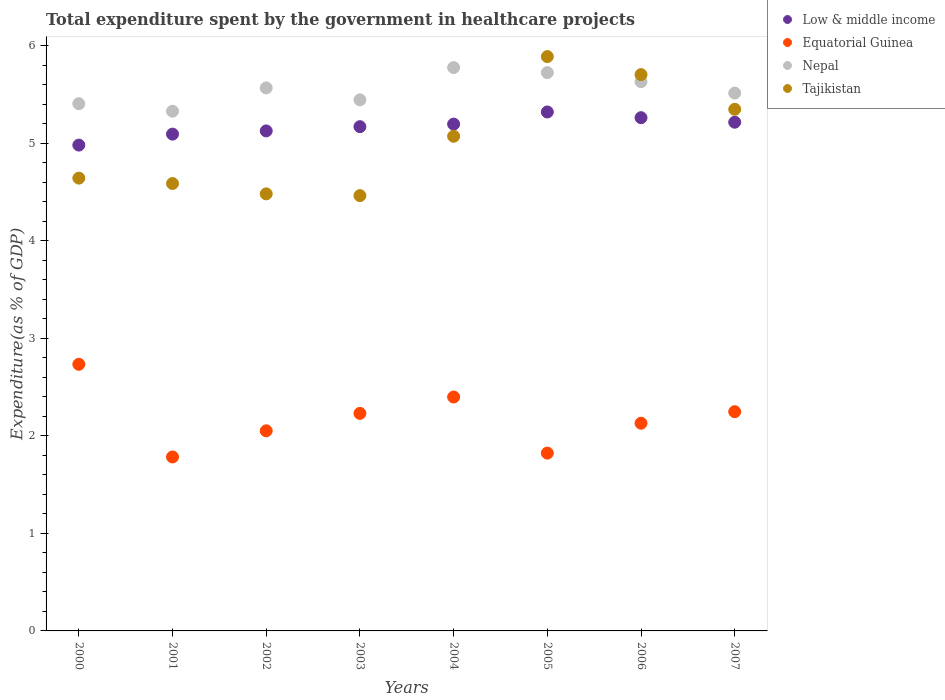What is the total expenditure spent by the government in healthcare projects in Tajikistan in 2004?
Your response must be concise. 5.07. Across all years, what is the maximum total expenditure spent by the government in healthcare projects in Equatorial Guinea?
Offer a very short reply. 2.73. Across all years, what is the minimum total expenditure spent by the government in healthcare projects in Low & middle income?
Provide a short and direct response. 4.98. What is the total total expenditure spent by the government in healthcare projects in Tajikistan in the graph?
Provide a succinct answer. 40.17. What is the difference between the total expenditure spent by the government in healthcare projects in Low & middle income in 2000 and that in 2006?
Keep it short and to the point. -0.28. What is the difference between the total expenditure spent by the government in healthcare projects in Equatorial Guinea in 2006 and the total expenditure spent by the government in healthcare projects in Low & middle income in 2001?
Make the answer very short. -2.96. What is the average total expenditure spent by the government in healthcare projects in Low & middle income per year?
Ensure brevity in your answer.  5.17. In the year 2006, what is the difference between the total expenditure spent by the government in healthcare projects in Tajikistan and total expenditure spent by the government in healthcare projects in Equatorial Guinea?
Ensure brevity in your answer.  3.57. In how many years, is the total expenditure spent by the government in healthcare projects in Equatorial Guinea greater than 5.4 %?
Keep it short and to the point. 0. What is the ratio of the total expenditure spent by the government in healthcare projects in Low & middle income in 2000 to that in 2002?
Your answer should be compact. 0.97. Is the total expenditure spent by the government in healthcare projects in Equatorial Guinea in 2003 less than that in 2004?
Provide a short and direct response. Yes. What is the difference between the highest and the second highest total expenditure spent by the government in healthcare projects in Tajikistan?
Provide a succinct answer. 0.18. What is the difference between the highest and the lowest total expenditure spent by the government in healthcare projects in Nepal?
Offer a very short reply. 0.45. Is the sum of the total expenditure spent by the government in healthcare projects in Equatorial Guinea in 2000 and 2004 greater than the maximum total expenditure spent by the government in healthcare projects in Tajikistan across all years?
Make the answer very short. No. Is it the case that in every year, the sum of the total expenditure spent by the government in healthcare projects in Tajikistan and total expenditure spent by the government in healthcare projects in Nepal  is greater than the total expenditure spent by the government in healthcare projects in Equatorial Guinea?
Your answer should be compact. Yes. Is the total expenditure spent by the government in healthcare projects in Equatorial Guinea strictly less than the total expenditure spent by the government in healthcare projects in Tajikistan over the years?
Make the answer very short. Yes. How many dotlines are there?
Your answer should be compact. 4. How many years are there in the graph?
Your response must be concise. 8. What is the difference between two consecutive major ticks on the Y-axis?
Provide a short and direct response. 1. Does the graph contain grids?
Provide a short and direct response. No. How are the legend labels stacked?
Your answer should be very brief. Vertical. What is the title of the graph?
Your answer should be very brief. Total expenditure spent by the government in healthcare projects. Does "Cuba" appear as one of the legend labels in the graph?
Offer a very short reply. No. What is the label or title of the X-axis?
Provide a short and direct response. Years. What is the label or title of the Y-axis?
Make the answer very short. Expenditure(as % of GDP). What is the Expenditure(as % of GDP) of Low & middle income in 2000?
Your answer should be very brief. 4.98. What is the Expenditure(as % of GDP) in Equatorial Guinea in 2000?
Give a very brief answer. 2.73. What is the Expenditure(as % of GDP) in Nepal in 2000?
Provide a short and direct response. 5.4. What is the Expenditure(as % of GDP) in Tajikistan in 2000?
Offer a terse response. 4.64. What is the Expenditure(as % of GDP) of Low & middle income in 2001?
Offer a very short reply. 5.09. What is the Expenditure(as % of GDP) in Equatorial Guinea in 2001?
Offer a terse response. 1.78. What is the Expenditure(as % of GDP) in Nepal in 2001?
Your response must be concise. 5.33. What is the Expenditure(as % of GDP) of Tajikistan in 2001?
Your answer should be very brief. 4.59. What is the Expenditure(as % of GDP) of Low & middle income in 2002?
Provide a short and direct response. 5.13. What is the Expenditure(as % of GDP) in Equatorial Guinea in 2002?
Your answer should be compact. 2.05. What is the Expenditure(as % of GDP) of Nepal in 2002?
Your response must be concise. 5.57. What is the Expenditure(as % of GDP) in Tajikistan in 2002?
Ensure brevity in your answer.  4.48. What is the Expenditure(as % of GDP) in Low & middle income in 2003?
Offer a very short reply. 5.17. What is the Expenditure(as % of GDP) in Equatorial Guinea in 2003?
Your response must be concise. 2.23. What is the Expenditure(as % of GDP) of Nepal in 2003?
Your answer should be very brief. 5.44. What is the Expenditure(as % of GDP) in Tajikistan in 2003?
Ensure brevity in your answer.  4.46. What is the Expenditure(as % of GDP) in Low & middle income in 2004?
Your answer should be very brief. 5.19. What is the Expenditure(as % of GDP) in Equatorial Guinea in 2004?
Your answer should be very brief. 2.4. What is the Expenditure(as % of GDP) of Nepal in 2004?
Keep it short and to the point. 5.77. What is the Expenditure(as % of GDP) of Tajikistan in 2004?
Ensure brevity in your answer.  5.07. What is the Expenditure(as % of GDP) of Low & middle income in 2005?
Your answer should be compact. 5.32. What is the Expenditure(as % of GDP) of Equatorial Guinea in 2005?
Provide a short and direct response. 1.82. What is the Expenditure(as % of GDP) of Nepal in 2005?
Keep it short and to the point. 5.72. What is the Expenditure(as % of GDP) in Tajikistan in 2005?
Make the answer very short. 5.89. What is the Expenditure(as % of GDP) in Low & middle income in 2006?
Make the answer very short. 5.26. What is the Expenditure(as % of GDP) in Equatorial Guinea in 2006?
Offer a very short reply. 2.13. What is the Expenditure(as % of GDP) in Nepal in 2006?
Make the answer very short. 5.63. What is the Expenditure(as % of GDP) of Tajikistan in 2006?
Offer a very short reply. 5.7. What is the Expenditure(as % of GDP) of Low & middle income in 2007?
Keep it short and to the point. 5.21. What is the Expenditure(as % of GDP) of Equatorial Guinea in 2007?
Keep it short and to the point. 2.25. What is the Expenditure(as % of GDP) of Nepal in 2007?
Give a very brief answer. 5.51. What is the Expenditure(as % of GDP) in Tajikistan in 2007?
Give a very brief answer. 5.35. Across all years, what is the maximum Expenditure(as % of GDP) of Low & middle income?
Make the answer very short. 5.32. Across all years, what is the maximum Expenditure(as % of GDP) of Equatorial Guinea?
Make the answer very short. 2.73. Across all years, what is the maximum Expenditure(as % of GDP) in Nepal?
Keep it short and to the point. 5.77. Across all years, what is the maximum Expenditure(as % of GDP) in Tajikistan?
Provide a succinct answer. 5.89. Across all years, what is the minimum Expenditure(as % of GDP) of Low & middle income?
Provide a short and direct response. 4.98. Across all years, what is the minimum Expenditure(as % of GDP) in Equatorial Guinea?
Offer a very short reply. 1.78. Across all years, what is the minimum Expenditure(as % of GDP) of Nepal?
Ensure brevity in your answer.  5.33. Across all years, what is the minimum Expenditure(as % of GDP) in Tajikistan?
Offer a very short reply. 4.46. What is the total Expenditure(as % of GDP) in Low & middle income in the graph?
Make the answer very short. 41.35. What is the total Expenditure(as % of GDP) in Equatorial Guinea in the graph?
Ensure brevity in your answer.  17.39. What is the total Expenditure(as % of GDP) in Nepal in the graph?
Keep it short and to the point. 44.38. What is the total Expenditure(as % of GDP) in Tajikistan in the graph?
Provide a succinct answer. 40.17. What is the difference between the Expenditure(as % of GDP) in Low & middle income in 2000 and that in 2001?
Offer a very short reply. -0.11. What is the difference between the Expenditure(as % of GDP) of Equatorial Guinea in 2000 and that in 2001?
Your response must be concise. 0.95. What is the difference between the Expenditure(as % of GDP) in Nepal in 2000 and that in 2001?
Provide a succinct answer. 0.08. What is the difference between the Expenditure(as % of GDP) in Tajikistan in 2000 and that in 2001?
Your answer should be compact. 0.06. What is the difference between the Expenditure(as % of GDP) in Low & middle income in 2000 and that in 2002?
Give a very brief answer. -0.15. What is the difference between the Expenditure(as % of GDP) of Equatorial Guinea in 2000 and that in 2002?
Give a very brief answer. 0.68. What is the difference between the Expenditure(as % of GDP) of Nepal in 2000 and that in 2002?
Offer a very short reply. -0.16. What is the difference between the Expenditure(as % of GDP) in Tajikistan in 2000 and that in 2002?
Give a very brief answer. 0.16. What is the difference between the Expenditure(as % of GDP) in Low & middle income in 2000 and that in 2003?
Your response must be concise. -0.19. What is the difference between the Expenditure(as % of GDP) of Equatorial Guinea in 2000 and that in 2003?
Offer a terse response. 0.5. What is the difference between the Expenditure(as % of GDP) of Nepal in 2000 and that in 2003?
Offer a very short reply. -0.04. What is the difference between the Expenditure(as % of GDP) in Tajikistan in 2000 and that in 2003?
Offer a very short reply. 0.18. What is the difference between the Expenditure(as % of GDP) of Low & middle income in 2000 and that in 2004?
Keep it short and to the point. -0.21. What is the difference between the Expenditure(as % of GDP) in Equatorial Guinea in 2000 and that in 2004?
Provide a succinct answer. 0.34. What is the difference between the Expenditure(as % of GDP) of Nepal in 2000 and that in 2004?
Offer a very short reply. -0.37. What is the difference between the Expenditure(as % of GDP) in Tajikistan in 2000 and that in 2004?
Keep it short and to the point. -0.43. What is the difference between the Expenditure(as % of GDP) of Low & middle income in 2000 and that in 2005?
Provide a short and direct response. -0.34. What is the difference between the Expenditure(as % of GDP) in Equatorial Guinea in 2000 and that in 2005?
Keep it short and to the point. 0.91. What is the difference between the Expenditure(as % of GDP) of Nepal in 2000 and that in 2005?
Provide a succinct answer. -0.32. What is the difference between the Expenditure(as % of GDP) of Tajikistan in 2000 and that in 2005?
Provide a succinct answer. -1.25. What is the difference between the Expenditure(as % of GDP) in Low & middle income in 2000 and that in 2006?
Offer a terse response. -0.28. What is the difference between the Expenditure(as % of GDP) in Equatorial Guinea in 2000 and that in 2006?
Give a very brief answer. 0.6. What is the difference between the Expenditure(as % of GDP) of Nepal in 2000 and that in 2006?
Keep it short and to the point. -0.23. What is the difference between the Expenditure(as % of GDP) of Tajikistan in 2000 and that in 2006?
Make the answer very short. -1.06. What is the difference between the Expenditure(as % of GDP) in Low & middle income in 2000 and that in 2007?
Give a very brief answer. -0.23. What is the difference between the Expenditure(as % of GDP) of Equatorial Guinea in 2000 and that in 2007?
Provide a short and direct response. 0.49. What is the difference between the Expenditure(as % of GDP) of Nepal in 2000 and that in 2007?
Your response must be concise. -0.11. What is the difference between the Expenditure(as % of GDP) of Tajikistan in 2000 and that in 2007?
Give a very brief answer. -0.71. What is the difference between the Expenditure(as % of GDP) of Low & middle income in 2001 and that in 2002?
Offer a terse response. -0.03. What is the difference between the Expenditure(as % of GDP) of Equatorial Guinea in 2001 and that in 2002?
Your answer should be compact. -0.27. What is the difference between the Expenditure(as % of GDP) of Nepal in 2001 and that in 2002?
Give a very brief answer. -0.24. What is the difference between the Expenditure(as % of GDP) of Tajikistan in 2001 and that in 2002?
Keep it short and to the point. 0.11. What is the difference between the Expenditure(as % of GDP) of Low & middle income in 2001 and that in 2003?
Your answer should be compact. -0.08. What is the difference between the Expenditure(as % of GDP) in Equatorial Guinea in 2001 and that in 2003?
Ensure brevity in your answer.  -0.45. What is the difference between the Expenditure(as % of GDP) in Nepal in 2001 and that in 2003?
Your response must be concise. -0.12. What is the difference between the Expenditure(as % of GDP) in Tajikistan in 2001 and that in 2003?
Offer a terse response. 0.12. What is the difference between the Expenditure(as % of GDP) of Low & middle income in 2001 and that in 2004?
Your response must be concise. -0.1. What is the difference between the Expenditure(as % of GDP) in Equatorial Guinea in 2001 and that in 2004?
Your answer should be compact. -0.61. What is the difference between the Expenditure(as % of GDP) of Nepal in 2001 and that in 2004?
Your response must be concise. -0.45. What is the difference between the Expenditure(as % of GDP) in Tajikistan in 2001 and that in 2004?
Provide a short and direct response. -0.48. What is the difference between the Expenditure(as % of GDP) in Low & middle income in 2001 and that in 2005?
Keep it short and to the point. -0.23. What is the difference between the Expenditure(as % of GDP) in Equatorial Guinea in 2001 and that in 2005?
Provide a short and direct response. -0.04. What is the difference between the Expenditure(as % of GDP) of Nepal in 2001 and that in 2005?
Give a very brief answer. -0.4. What is the difference between the Expenditure(as % of GDP) in Tajikistan in 2001 and that in 2005?
Give a very brief answer. -1.3. What is the difference between the Expenditure(as % of GDP) of Low & middle income in 2001 and that in 2006?
Ensure brevity in your answer.  -0.17. What is the difference between the Expenditure(as % of GDP) of Equatorial Guinea in 2001 and that in 2006?
Ensure brevity in your answer.  -0.35. What is the difference between the Expenditure(as % of GDP) of Nepal in 2001 and that in 2006?
Your response must be concise. -0.3. What is the difference between the Expenditure(as % of GDP) of Tajikistan in 2001 and that in 2006?
Your response must be concise. -1.12. What is the difference between the Expenditure(as % of GDP) in Low & middle income in 2001 and that in 2007?
Make the answer very short. -0.12. What is the difference between the Expenditure(as % of GDP) of Equatorial Guinea in 2001 and that in 2007?
Provide a succinct answer. -0.46. What is the difference between the Expenditure(as % of GDP) in Nepal in 2001 and that in 2007?
Your answer should be compact. -0.19. What is the difference between the Expenditure(as % of GDP) in Tajikistan in 2001 and that in 2007?
Give a very brief answer. -0.76. What is the difference between the Expenditure(as % of GDP) in Low & middle income in 2002 and that in 2003?
Offer a terse response. -0.04. What is the difference between the Expenditure(as % of GDP) in Equatorial Guinea in 2002 and that in 2003?
Your answer should be compact. -0.18. What is the difference between the Expenditure(as % of GDP) in Nepal in 2002 and that in 2003?
Keep it short and to the point. 0.12. What is the difference between the Expenditure(as % of GDP) of Tajikistan in 2002 and that in 2003?
Your answer should be compact. 0.02. What is the difference between the Expenditure(as % of GDP) of Low & middle income in 2002 and that in 2004?
Keep it short and to the point. -0.07. What is the difference between the Expenditure(as % of GDP) of Equatorial Guinea in 2002 and that in 2004?
Offer a terse response. -0.35. What is the difference between the Expenditure(as % of GDP) in Nepal in 2002 and that in 2004?
Your answer should be compact. -0.21. What is the difference between the Expenditure(as % of GDP) of Tajikistan in 2002 and that in 2004?
Provide a short and direct response. -0.59. What is the difference between the Expenditure(as % of GDP) in Low & middle income in 2002 and that in 2005?
Make the answer very short. -0.19. What is the difference between the Expenditure(as % of GDP) of Equatorial Guinea in 2002 and that in 2005?
Your answer should be very brief. 0.23. What is the difference between the Expenditure(as % of GDP) of Nepal in 2002 and that in 2005?
Your answer should be very brief. -0.16. What is the difference between the Expenditure(as % of GDP) in Tajikistan in 2002 and that in 2005?
Ensure brevity in your answer.  -1.41. What is the difference between the Expenditure(as % of GDP) of Low & middle income in 2002 and that in 2006?
Your answer should be compact. -0.14. What is the difference between the Expenditure(as % of GDP) in Equatorial Guinea in 2002 and that in 2006?
Provide a succinct answer. -0.08. What is the difference between the Expenditure(as % of GDP) in Nepal in 2002 and that in 2006?
Your answer should be compact. -0.06. What is the difference between the Expenditure(as % of GDP) of Tajikistan in 2002 and that in 2006?
Make the answer very short. -1.22. What is the difference between the Expenditure(as % of GDP) of Low & middle income in 2002 and that in 2007?
Provide a succinct answer. -0.09. What is the difference between the Expenditure(as % of GDP) of Equatorial Guinea in 2002 and that in 2007?
Your answer should be very brief. -0.2. What is the difference between the Expenditure(as % of GDP) of Nepal in 2002 and that in 2007?
Offer a very short reply. 0.05. What is the difference between the Expenditure(as % of GDP) in Tajikistan in 2002 and that in 2007?
Your answer should be compact. -0.87. What is the difference between the Expenditure(as % of GDP) in Low & middle income in 2003 and that in 2004?
Your answer should be very brief. -0.03. What is the difference between the Expenditure(as % of GDP) in Equatorial Guinea in 2003 and that in 2004?
Ensure brevity in your answer.  -0.17. What is the difference between the Expenditure(as % of GDP) in Nepal in 2003 and that in 2004?
Make the answer very short. -0.33. What is the difference between the Expenditure(as % of GDP) of Tajikistan in 2003 and that in 2004?
Provide a succinct answer. -0.61. What is the difference between the Expenditure(as % of GDP) in Low & middle income in 2003 and that in 2005?
Your response must be concise. -0.15. What is the difference between the Expenditure(as % of GDP) of Equatorial Guinea in 2003 and that in 2005?
Your answer should be compact. 0.41. What is the difference between the Expenditure(as % of GDP) in Nepal in 2003 and that in 2005?
Your answer should be compact. -0.28. What is the difference between the Expenditure(as % of GDP) in Tajikistan in 2003 and that in 2005?
Offer a very short reply. -1.43. What is the difference between the Expenditure(as % of GDP) in Low & middle income in 2003 and that in 2006?
Your answer should be compact. -0.09. What is the difference between the Expenditure(as % of GDP) of Equatorial Guinea in 2003 and that in 2006?
Provide a short and direct response. 0.1. What is the difference between the Expenditure(as % of GDP) in Nepal in 2003 and that in 2006?
Make the answer very short. -0.19. What is the difference between the Expenditure(as % of GDP) in Tajikistan in 2003 and that in 2006?
Provide a short and direct response. -1.24. What is the difference between the Expenditure(as % of GDP) in Low & middle income in 2003 and that in 2007?
Your response must be concise. -0.05. What is the difference between the Expenditure(as % of GDP) of Equatorial Guinea in 2003 and that in 2007?
Provide a short and direct response. -0.02. What is the difference between the Expenditure(as % of GDP) in Nepal in 2003 and that in 2007?
Provide a succinct answer. -0.07. What is the difference between the Expenditure(as % of GDP) in Tajikistan in 2003 and that in 2007?
Ensure brevity in your answer.  -0.88. What is the difference between the Expenditure(as % of GDP) of Low & middle income in 2004 and that in 2005?
Ensure brevity in your answer.  -0.12. What is the difference between the Expenditure(as % of GDP) of Equatorial Guinea in 2004 and that in 2005?
Your answer should be compact. 0.57. What is the difference between the Expenditure(as % of GDP) in Nepal in 2004 and that in 2005?
Your answer should be compact. 0.05. What is the difference between the Expenditure(as % of GDP) of Tajikistan in 2004 and that in 2005?
Offer a terse response. -0.82. What is the difference between the Expenditure(as % of GDP) of Low & middle income in 2004 and that in 2006?
Give a very brief answer. -0.07. What is the difference between the Expenditure(as % of GDP) in Equatorial Guinea in 2004 and that in 2006?
Your answer should be very brief. 0.27. What is the difference between the Expenditure(as % of GDP) of Nepal in 2004 and that in 2006?
Ensure brevity in your answer.  0.14. What is the difference between the Expenditure(as % of GDP) of Tajikistan in 2004 and that in 2006?
Provide a succinct answer. -0.63. What is the difference between the Expenditure(as % of GDP) of Low & middle income in 2004 and that in 2007?
Offer a terse response. -0.02. What is the difference between the Expenditure(as % of GDP) in Equatorial Guinea in 2004 and that in 2007?
Keep it short and to the point. 0.15. What is the difference between the Expenditure(as % of GDP) of Nepal in 2004 and that in 2007?
Offer a terse response. 0.26. What is the difference between the Expenditure(as % of GDP) in Tajikistan in 2004 and that in 2007?
Your response must be concise. -0.28. What is the difference between the Expenditure(as % of GDP) in Low & middle income in 2005 and that in 2006?
Ensure brevity in your answer.  0.06. What is the difference between the Expenditure(as % of GDP) in Equatorial Guinea in 2005 and that in 2006?
Your answer should be very brief. -0.31. What is the difference between the Expenditure(as % of GDP) in Nepal in 2005 and that in 2006?
Give a very brief answer. 0.09. What is the difference between the Expenditure(as % of GDP) in Tajikistan in 2005 and that in 2006?
Give a very brief answer. 0.18. What is the difference between the Expenditure(as % of GDP) of Low & middle income in 2005 and that in 2007?
Offer a terse response. 0.1. What is the difference between the Expenditure(as % of GDP) in Equatorial Guinea in 2005 and that in 2007?
Your response must be concise. -0.42. What is the difference between the Expenditure(as % of GDP) of Nepal in 2005 and that in 2007?
Offer a very short reply. 0.21. What is the difference between the Expenditure(as % of GDP) in Tajikistan in 2005 and that in 2007?
Make the answer very short. 0.54. What is the difference between the Expenditure(as % of GDP) in Low & middle income in 2006 and that in 2007?
Provide a short and direct response. 0.05. What is the difference between the Expenditure(as % of GDP) in Equatorial Guinea in 2006 and that in 2007?
Offer a terse response. -0.12. What is the difference between the Expenditure(as % of GDP) of Nepal in 2006 and that in 2007?
Make the answer very short. 0.12. What is the difference between the Expenditure(as % of GDP) of Tajikistan in 2006 and that in 2007?
Keep it short and to the point. 0.36. What is the difference between the Expenditure(as % of GDP) of Low & middle income in 2000 and the Expenditure(as % of GDP) of Equatorial Guinea in 2001?
Your answer should be compact. 3.2. What is the difference between the Expenditure(as % of GDP) of Low & middle income in 2000 and the Expenditure(as % of GDP) of Nepal in 2001?
Provide a short and direct response. -0.35. What is the difference between the Expenditure(as % of GDP) in Low & middle income in 2000 and the Expenditure(as % of GDP) in Tajikistan in 2001?
Make the answer very short. 0.39. What is the difference between the Expenditure(as % of GDP) in Equatorial Guinea in 2000 and the Expenditure(as % of GDP) in Nepal in 2001?
Make the answer very short. -2.59. What is the difference between the Expenditure(as % of GDP) in Equatorial Guinea in 2000 and the Expenditure(as % of GDP) in Tajikistan in 2001?
Make the answer very short. -1.85. What is the difference between the Expenditure(as % of GDP) of Nepal in 2000 and the Expenditure(as % of GDP) of Tajikistan in 2001?
Make the answer very short. 0.82. What is the difference between the Expenditure(as % of GDP) in Low & middle income in 2000 and the Expenditure(as % of GDP) in Equatorial Guinea in 2002?
Keep it short and to the point. 2.93. What is the difference between the Expenditure(as % of GDP) of Low & middle income in 2000 and the Expenditure(as % of GDP) of Nepal in 2002?
Make the answer very short. -0.59. What is the difference between the Expenditure(as % of GDP) of Low & middle income in 2000 and the Expenditure(as % of GDP) of Tajikistan in 2002?
Provide a short and direct response. 0.5. What is the difference between the Expenditure(as % of GDP) of Equatorial Guinea in 2000 and the Expenditure(as % of GDP) of Nepal in 2002?
Give a very brief answer. -2.83. What is the difference between the Expenditure(as % of GDP) in Equatorial Guinea in 2000 and the Expenditure(as % of GDP) in Tajikistan in 2002?
Your response must be concise. -1.75. What is the difference between the Expenditure(as % of GDP) in Nepal in 2000 and the Expenditure(as % of GDP) in Tajikistan in 2002?
Ensure brevity in your answer.  0.92. What is the difference between the Expenditure(as % of GDP) of Low & middle income in 2000 and the Expenditure(as % of GDP) of Equatorial Guinea in 2003?
Offer a terse response. 2.75. What is the difference between the Expenditure(as % of GDP) of Low & middle income in 2000 and the Expenditure(as % of GDP) of Nepal in 2003?
Offer a terse response. -0.46. What is the difference between the Expenditure(as % of GDP) in Low & middle income in 2000 and the Expenditure(as % of GDP) in Tajikistan in 2003?
Offer a very short reply. 0.52. What is the difference between the Expenditure(as % of GDP) of Equatorial Guinea in 2000 and the Expenditure(as % of GDP) of Nepal in 2003?
Give a very brief answer. -2.71. What is the difference between the Expenditure(as % of GDP) in Equatorial Guinea in 2000 and the Expenditure(as % of GDP) in Tajikistan in 2003?
Offer a very short reply. -1.73. What is the difference between the Expenditure(as % of GDP) in Nepal in 2000 and the Expenditure(as % of GDP) in Tajikistan in 2003?
Provide a succinct answer. 0.94. What is the difference between the Expenditure(as % of GDP) of Low & middle income in 2000 and the Expenditure(as % of GDP) of Equatorial Guinea in 2004?
Your answer should be very brief. 2.58. What is the difference between the Expenditure(as % of GDP) in Low & middle income in 2000 and the Expenditure(as % of GDP) in Nepal in 2004?
Offer a very short reply. -0.79. What is the difference between the Expenditure(as % of GDP) of Low & middle income in 2000 and the Expenditure(as % of GDP) of Tajikistan in 2004?
Provide a short and direct response. -0.09. What is the difference between the Expenditure(as % of GDP) in Equatorial Guinea in 2000 and the Expenditure(as % of GDP) in Nepal in 2004?
Provide a short and direct response. -3.04. What is the difference between the Expenditure(as % of GDP) in Equatorial Guinea in 2000 and the Expenditure(as % of GDP) in Tajikistan in 2004?
Offer a very short reply. -2.34. What is the difference between the Expenditure(as % of GDP) of Nepal in 2000 and the Expenditure(as % of GDP) of Tajikistan in 2004?
Offer a terse response. 0.33. What is the difference between the Expenditure(as % of GDP) in Low & middle income in 2000 and the Expenditure(as % of GDP) in Equatorial Guinea in 2005?
Provide a short and direct response. 3.16. What is the difference between the Expenditure(as % of GDP) in Low & middle income in 2000 and the Expenditure(as % of GDP) in Nepal in 2005?
Your answer should be compact. -0.74. What is the difference between the Expenditure(as % of GDP) of Low & middle income in 2000 and the Expenditure(as % of GDP) of Tajikistan in 2005?
Your answer should be very brief. -0.91. What is the difference between the Expenditure(as % of GDP) of Equatorial Guinea in 2000 and the Expenditure(as % of GDP) of Nepal in 2005?
Give a very brief answer. -2.99. What is the difference between the Expenditure(as % of GDP) in Equatorial Guinea in 2000 and the Expenditure(as % of GDP) in Tajikistan in 2005?
Provide a succinct answer. -3.15. What is the difference between the Expenditure(as % of GDP) in Nepal in 2000 and the Expenditure(as % of GDP) in Tajikistan in 2005?
Your response must be concise. -0.48. What is the difference between the Expenditure(as % of GDP) in Low & middle income in 2000 and the Expenditure(as % of GDP) in Equatorial Guinea in 2006?
Your answer should be very brief. 2.85. What is the difference between the Expenditure(as % of GDP) of Low & middle income in 2000 and the Expenditure(as % of GDP) of Nepal in 2006?
Your answer should be very brief. -0.65. What is the difference between the Expenditure(as % of GDP) of Low & middle income in 2000 and the Expenditure(as % of GDP) of Tajikistan in 2006?
Your answer should be very brief. -0.72. What is the difference between the Expenditure(as % of GDP) in Equatorial Guinea in 2000 and the Expenditure(as % of GDP) in Nepal in 2006?
Offer a terse response. -2.9. What is the difference between the Expenditure(as % of GDP) in Equatorial Guinea in 2000 and the Expenditure(as % of GDP) in Tajikistan in 2006?
Offer a very short reply. -2.97. What is the difference between the Expenditure(as % of GDP) in Nepal in 2000 and the Expenditure(as % of GDP) in Tajikistan in 2006?
Your answer should be very brief. -0.3. What is the difference between the Expenditure(as % of GDP) of Low & middle income in 2000 and the Expenditure(as % of GDP) of Equatorial Guinea in 2007?
Your response must be concise. 2.73. What is the difference between the Expenditure(as % of GDP) in Low & middle income in 2000 and the Expenditure(as % of GDP) in Nepal in 2007?
Offer a very short reply. -0.53. What is the difference between the Expenditure(as % of GDP) in Low & middle income in 2000 and the Expenditure(as % of GDP) in Tajikistan in 2007?
Ensure brevity in your answer.  -0.37. What is the difference between the Expenditure(as % of GDP) of Equatorial Guinea in 2000 and the Expenditure(as % of GDP) of Nepal in 2007?
Offer a very short reply. -2.78. What is the difference between the Expenditure(as % of GDP) of Equatorial Guinea in 2000 and the Expenditure(as % of GDP) of Tajikistan in 2007?
Ensure brevity in your answer.  -2.61. What is the difference between the Expenditure(as % of GDP) of Nepal in 2000 and the Expenditure(as % of GDP) of Tajikistan in 2007?
Keep it short and to the point. 0.06. What is the difference between the Expenditure(as % of GDP) of Low & middle income in 2001 and the Expenditure(as % of GDP) of Equatorial Guinea in 2002?
Your answer should be compact. 3.04. What is the difference between the Expenditure(as % of GDP) of Low & middle income in 2001 and the Expenditure(as % of GDP) of Nepal in 2002?
Your answer should be compact. -0.47. What is the difference between the Expenditure(as % of GDP) in Low & middle income in 2001 and the Expenditure(as % of GDP) in Tajikistan in 2002?
Offer a terse response. 0.61. What is the difference between the Expenditure(as % of GDP) of Equatorial Guinea in 2001 and the Expenditure(as % of GDP) of Nepal in 2002?
Provide a succinct answer. -3.78. What is the difference between the Expenditure(as % of GDP) in Equatorial Guinea in 2001 and the Expenditure(as % of GDP) in Tajikistan in 2002?
Provide a succinct answer. -2.7. What is the difference between the Expenditure(as % of GDP) of Nepal in 2001 and the Expenditure(as % of GDP) of Tajikistan in 2002?
Offer a very short reply. 0.85. What is the difference between the Expenditure(as % of GDP) of Low & middle income in 2001 and the Expenditure(as % of GDP) of Equatorial Guinea in 2003?
Offer a terse response. 2.86. What is the difference between the Expenditure(as % of GDP) in Low & middle income in 2001 and the Expenditure(as % of GDP) in Nepal in 2003?
Keep it short and to the point. -0.35. What is the difference between the Expenditure(as % of GDP) of Low & middle income in 2001 and the Expenditure(as % of GDP) of Tajikistan in 2003?
Keep it short and to the point. 0.63. What is the difference between the Expenditure(as % of GDP) of Equatorial Guinea in 2001 and the Expenditure(as % of GDP) of Nepal in 2003?
Provide a succinct answer. -3.66. What is the difference between the Expenditure(as % of GDP) in Equatorial Guinea in 2001 and the Expenditure(as % of GDP) in Tajikistan in 2003?
Provide a succinct answer. -2.68. What is the difference between the Expenditure(as % of GDP) of Nepal in 2001 and the Expenditure(as % of GDP) of Tajikistan in 2003?
Make the answer very short. 0.87. What is the difference between the Expenditure(as % of GDP) of Low & middle income in 2001 and the Expenditure(as % of GDP) of Equatorial Guinea in 2004?
Make the answer very short. 2.69. What is the difference between the Expenditure(as % of GDP) of Low & middle income in 2001 and the Expenditure(as % of GDP) of Nepal in 2004?
Ensure brevity in your answer.  -0.68. What is the difference between the Expenditure(as % of GDP) in Low & middle income in 2001 and the Expenditure(as % of GDP) in Tajikistan in 2004?
Your answer should be very brief. 0.02. What is the difference between the Expenditure(as % of GDP) of Equatorial Guinea in 2001 and the Expenditure(as % of GDP) of Nepal in 2004?
Make the answer very short. -3.99. What is the difference between the Expenditure(as % of GDP) of Equatorial Guinea in 2001 and the Expenditure(as % of GDP) of Tajikistan in 2004?
Offer a very short reply. -3.29. What is the difference between the Expenditure(as % of GDP) in Nepal in 2001 and the Expenditure(as % of GDP) in Tajikistan in 2004?
Provide a short and direct response. 0.26. What is the difference between the Expenditure(as % of GDP) in Low & middle income in 2001 and the Expenditure(as % of GDP) in Equatorial Guinea in 2005?
Keep it short and to the point. 3.27. What is the difference between the Expenditure(as % of GDP) in Low & middle income in 2001 and the Expenditure(as % of GDP) in Nepal in 2005?
Your answer should be compact. -0.63. What is the difference between the Expenditure(as % of GDP) in Low & middle income in 2001 and the Expenditure(as % of GDP) in Tajikistan in 2005?
Provide a short and direct response. -0.79. What is the difference between the Expenditure(as % of GDP) in Equatorial Guinea in 2001 and the Expenditure(as % of GDP) in Nepal in 2005?
Your answer should be compact. -3.94. What is the difference between the Expenditure(as % of GDP) in Equatorial Guinea in 2001 and the Expenditure(as % of GDP) in Tajikistan in 2005?
Keep it short and to the point. -4.1. What is the difference between the Expenditure(as % of GDP) in Nepal in 2001 and the Expenditure(as % of GDP) in Tajikistan in 2005?
Offer a very short reply. -0.56. What is the difference between the Expenditure(as % of GDP) in Low & middle income in 2001 and the Expenditure(as % of GDP) in Equatorial Guinea in 2006?
Your answer should be compact. 2.96. What is the difference between the Expenditure(as % of GDP) in Low & middle income in 2001 and the Expenditure(as % of GDP) in Nepal in 2006?
Keep it short and to the point. -0.54. What is the difference between the Expenditure(as % of GDP) of Low & middle income in 2001 and the Expenditure(as % of GDP) of Tajikistan in 2006?
Make the answer very short. -0.61. What is the difference between the Expenditure(as % of GDP) in Equatorial Guinea in 2001 and the Expenditure(as % of GDP) in Nepal in 2006?
Provide a succinct answer. -3.85. What is the difference between the Expenditure(as % of GDP) in Equatorial Guinea in 2001 and the Expenditure(as % of GDP) in Tajikistan in 2006?
Offer a very short reply. -3.92. What is the difference between the Expenditure(as % of GDP) in Nepal in 2001 and the Expenditure(as % of GDP) in Tajikistan in 2006?
Make the answer very short. -0.38. What is the difference between the Expenditure(as % of GDP) of Low & middle income in 2001 and the Expenditure(as % of GDP) of Equatorial Guinea in 2007?
Your answer should be compact. 2.84. What is the difference between the Expenditure(as % of GDP) in Low & middle income in 2001 and the Expenditure(as % of GDP) in Nepal in 2007?
Make the answer very short. -0.42. What is the difference between the Expenditure(as % of GDP) of Low & middle income in 2001 and the Expenditure(as % of GDP) of Tajikistan in 2007?
Your response must be concise. -0.25. What is the difference between the Expenditure(as % of GDP) of Equatorial Guinea in 2001 and the Expenditure(as % of GDP) of Nepal in 2007?
Ensure brevity in your answer.  -3.73. What is the difference between the Expenditure(as % of GDP) of Equatorial Guinea in 2001 and the Expenditure(as % of GDP) of Tajikistan in 2007?
Your answer should be very brief. -3.56. What is the difference between the Expenditure(as % of GDP) in Nepal in 2001 and the Expenditure(as % of GDP) in Tajikistan in 2007?
Ensure brevity in your answer.  -0.02. What is the difference between the Expenditure(as % of GDP) of Low & middle income in 2002 and the Expenditure(as % of GDP) of Equatorial Guinea in 2003?
Provide a succinct answer. 2.9. What is the difference between the Expenditure(as % of GDP) in Low & middle income in 2002 and the Expenditure(as % of GDP) in Nepal in 2003?
Provide a short and direct response. -0.32. What is the difference between the Expenditure(as % of GDP) in Low & middle income in 2002 and the Expenditure(as % of GDP) in Tajikistan in 2003?
Keep it short and to the point. 0.66. What is the difference between the Expenditure(as % of GDP) of Equatorial Guinea in 2002 and the Expenditure(as % of GDP) of Nepal in 2003?
Your response must be concise. -3.39. What is the difference between the Expenditure(as % of GDP) of Equatorial Guinea in 2002 and the Expenditure(as % of GDP) of Tajikistan in 2003?
Provide a short and direct response. -2.41. What is the difference between the Expenditure(as % of GDP) of Nepal in 2002 and the Expenditure(as % of GDP) of Tajikistan in 2003?
Ensure brevity in your answer.  1.1. What is the difference between the Expenditure(as % of GDP) of Low & middle income in 2002 and the Expenditure(as % of GDP) of Equatorial Guinea in 2004?
Give a very brief answer. 2.73. What is the difference between the Expenditure(as % of GDP) of Low & middle income in 2002 and the Expenditure(as % of GDP) of Nepal in 2004?
Offer a very short reply. -0.65. What is the difference between the Expenditure(as % of GDP) in Low & middle income in 2002 and the Expenditure(as % of GDP) in Tajikistan in 2004?
Your answer should be very brief. 0.05. What is the difference between the Expenditure(as % of GDP) of Equatorial Guinea in 2002 and the Expenditure(as % of GDP) of Nepal in 2004?
Your answer should be compact. -3.72. What is the difference between the Expenditure(as % of GDP) in Equatorial Guinea in 2002 and the Expenditure(as % of GDP) in Tajikistan in 2004?
Ensure brevity in your answer.  -3.02. What is the difference between the Expenditure(as % of GDP) of Nepal in 2002 and the Expenditure(as % of GDP) of Tajikistan in 2004?
Make the answer very short. 0.5. What is the difference between the Expenditure(as % of GDP) of Low & middle income in 2002 and the Expenditure(as % of GDP) of Equatorial Guinea in 2005?
Keep it short and to the point. 3.3. What is the difference between the Expenditure(as % of GDP) of Low & middle income in 2002 and the Expenditure(as % of GDP) of Nepal in 2005?
Give a very brief answer. -0.6. What is the difference between the Expenditure(as % of GDP) of Low & middle income in 2002 and the Expenditure(as % of GDP) of Tajikistan in 2005?
Your response must be concise. -0.76. What is the difference between the Expenditure(as % of GDP) in Equatorial Guinea in 2002 and the Expenditure(as % of GDP) in Nepal in 2005?
Your answer should be compact. -3.67. What is the difference between the Expenditure(as % of GDP) in Equatorial Guinea in 2002 and the Expenditure(as % of GDP) in Tajikistan in 2005?
Your answer should be very brief. -3.84. What is the difference between the Expenditure(as % of GDP) in Nepal in 2002 and the Expenditure(as % of GDP) in Tajikistan in 2005?
Your answer should be compact. -0.32. What is the difference between the Expenditure(as % of GDP) in Low & middle income in 2002 and the Expenditure(as % of GDP) in Equatorial Guinea in 2006?
Provide a short and direct response. 3. What is the difference between the Expenditure(as % of GDP) of Low & middle income in 2002 and the Expenditure(as % of GDP) of Nepal in 2006?
Your answer should be compact. -0.5. What is the difference between the Expenditure(as % of GDP) in Low & middle income in 2002 and the Expenditure(as % of GDP) in Tajikistan in 2006?
Provide a short and direct response. -0.58. What is the difference between the Expenditure(as % of GDP) of Equatorial Guinea in 2002 and the Expenditure(as % of GDP) of Nepal in 2006?
Give a very brief answer. -3.58. What is the difference between the Expenditure(as % of GDP) of Equatorial Guinea in 2002 and the Expenditure(as % of GDP) of Tajikistan in 2006?
Provide a succinct answer. -3.65. What is the difference between the Expenditure(as % of GDP) of Nepal in 2002 and the Expenditure(as % of GDP) of Tajikistan in 2006?
Offer a terse response. -0.14. What is the difference between the Expenditure(as % of GDP) of Low & middle income in 2002 and the Expenditure(as % of GDP) of Equatorial Guinea in 2007?
Ensure brevity in your answer.  2.88. What is the difference between the Expenditure(as % of GDP) of Low & middle income in 2002 and the Expenditure(as % of GDP) of Nepal in 2007?
Ensure brevity in your answer.  -0.39. What is the difference between the Expenditure(as % of GDP) in Low & middle income in 2002 and the Expenditure(as % of GDP) in Tajikistan in 2007?
Offer a very short reply. -0.22. What is the difference between the Expenditure(as % of GDP) in Equatorial Guinea in 2002 and the Expenditure(as % of GDP) in Nepal in 2007?
Your response must be concise. -3.46. What is the difference between the Expenditure(as % of GDP) in Equatorial Guinea in 2002 and the Expenditure(as % of GDP) in Tajikistan in 2007?
Make the answer very short. -3.3. What is the difference between the Expenditure(as % of GDP) of Nepal in 2002 and the Expenditure(as % of GDP) of Tajikistan in 2007?
Offer a very short reply. 0.22. What is the difference between the Expenditure(as % of GDP) in Low & middle income in 2003 and the Expenditure(as % of GDP) in Equatorial Guinea in 2004?
Ensure brevity in your answer.  2.77. What is the difference between the Expenditure(as % of GDP) of Low & middle income in 2003 and the Expenditure(as % of GDP) of Nepal in 2004?
Provide a succinct answer. -0.61. What is the difference between the Expenditure(as % of GDP) in Low & middle income in 2003 and the Expenditure(as % of GDP) in Tajikistan in 2004?
Give a very brief answer. 0.1. What is the difference between the Expenditure(as % of GDP) in Equatorial Guinea in 2003 and the Expenditure(as % of GDP) in Nepal in 2004?
Offer a terse response. -3.54. What is the difference between the Expenditure(as % of GDP) in Equatorial Guinea in 2003 and the Expenditure(as % of GDP) in Tajikistan in 2004?
Give a very brief answer. -2.84. What is the difference between the Expenditure(as % of GDP) of Nepal in 2003 and the Expenditure(as % of GDP) of Tajikistan in 2004?
Your answer should be very brief. 0.37. What is the difference between the Expenditure(as % of GDP) in Low & middle income in 2003 and the Expenditure(as % of GDP) in Equatorial Guinea in 2005?
Your response must be concise. 3.35. What is the difference between the Expenditure(as % of GDP) in Low & middle income in 2003 and the Expenditure(as % of GDP) in Nepal in 2005?
Your answer should be very brief. -0.55. What is the difference between the Expenditure(as % of GDP) in Low & middle income in 2003 and the Expenditure(as % of GDP) in Tajikistan in 2005?
Give a very brief answer. -0.72. What is the difference between the Expenditure(as % of GDP) of Equatorial Guinea in 2003 and the Expenditure(as % of GDP) of Nepal in 2005?
Offer a very short reply. -3.49. What is the difference between the Expenditure(as % of GDP) of Equatorial Guinea in 2003 and the Expenditure(as % of GDP) of Tajikistan in 2005?
Offer a very short reply. -3.66. What is the difference between the Expenditure(as % of GDP) of Nepal in 2003 and the Expenditure(as % of GDP) of Tajikistan in 2005?
Offer a terse response. -0.44. What is the difference between the Expenditure(as % of GDP) in Low & middle income in 2003 and the Expenditure(as % of GDP) in Equatorial Guinea in 2006?
Offer a very short reply. 3.04. What is the difference between the Expenditure(as % of GDP) of Low & middle income in 2003 and the Expenditure(as % of GDP) of Nepal in 2006?
Your answer should be very brief. -0.46. What is the difference between the Expenditure(as % of GDP) of Low & middle income in 2003 and the Expenditure(as % of GDP) of Tajikistan in 2006?
Make the answer very short. -0.53. What is the difference between the Expenditure(as % of GDP) of Equatorial Guinea in 2003 and the Expenditure(as % of GDP) of Nepal in 2006?
Ensure brevity in your answer.  -3.4. What is the difference between the Expenditure(as % of GDP) in Equatorial Guinea in 2003 and the Expenditure(as % of GDP) in Tajikistan in 2006?
Keep it short and to the point. -3.47. What is the difference between the Expenditure(as % of GDP) in Nepal in 2003 and the Expenditure(as % of GDP) in Tajikistan in 2006?
Keep it short and to the point. -0.26. What is the difference between the Expenditure(as % of GDP) in Low & middle income in 2003 and the Expenditure(as % of GDP) in Equatorial Guinea in 2007?
Your response must be concise. 2.92. What is the difference between the Expenditure(as % of GDP) in Low & middle income in 2003 and the Expenditure(as % of GDP) in Nepal in 2007?
Give a very brief answer. -0.34. What is the difference between the Expenditure(as % of GDP) of Low & middle income in 2003 and the Expenditure(as % of GDP) of Tajikistan in 2007?
Ensure brevity in your answer.  -0.18. What is the difference between the Expenditure(as % of GDP) in Equatorial Guinea in 2003 and the Expenditure(as % of GDP) in Nepal in 2007?
Keep it short and to the point. -3.28. What is the difference between the Expenditure(as % of GDP) of Equatorial Guinea in 2003 and the Expenditure(as % of GDP) of Tajikistan in 2007?
Provide a short and direct response. -3.12. What is the difference between the Expenditure(as % of GDP) of Nepal in 2003 and the Expenditure(as % of GDP) of Tajikistan in 2007?
Your response must be concise. 0.1. What is the difference between the Expenditure(as % of GDP) of Low & middle income in 2004 and the Expenditure(as % of GDP) of Equatorial Guinea in 2005?
Provide a succinct answer. 3.37. What is the difference between the Expenditure(as % of GDP) in Low & middle income in 2004 and the Expenditure(as % of GDP) in Nepal in 2005?
Offer a terse response. -0.53. What is the difference between the Expenditure(as % of GDP) of Low & middle income in 2004 and the Expenditure(as % of GDP) of Tajikistan in 2005?
Give a very brief answer. -0.69. What is the difference between the Expenditure(as % of GDP) in Equatorial Guinea in 2004 and the Expenditure(as % of GDP) in Nepal in 2005?
Offer a terse response. -3.33. What is the difference between the Expenditure(as % of GDP) of Equatorial Guinea in 2004 and the Expenditure(as % of GDP) of Tajikistan in 2005?
Give a very brief answer. -3.49. What is the difference between the Expenditure(as % of GDP) of Nepal in 2004 and the Expenditure(as % of GDP) of Tajikistan in 2005?
Your response must be concise. -0.11. What is the difference between the Expenditure(as % of GDP) of Low & middle income in 2004 and the Expenditure(as % of GDP) of Equatorial Guinea in 2006?
Make the answer very short. 3.07. What is the difference between the Expenditure(as % of GDP) of Low & middle income in 2004 and the Expenditure(as % of GDP) of Nepal in 2006?
Provide a short and direct response. -0.43. What is the difference between the Expenditure(as % of GDP) of Low & middle income in 2004 and the Expenditure(as % of GDP) of Tajikistan in 2006?
Keep it short and to the point. -0.51. What is the difference between the Expenditure(as % of GDP) of Equatorial Guinea in 2004 and the Expenditure(as % of GDP) of Nepal in 2006?
Your answer should be very brief. -3.23. What is the difference between the Expenditure(as % of GDP) in Equatorial Guinea in 2004 and the Expenditure(as % of GDP) in Tajikistan in 2006?
Ensure brevity in your answer.  -3.3. What is the difference between the Expenditure(as % of GDP) in Nepal in 2004 and the Expenditure(as % of GDP) in Tajikistan in 2006?
Give a very brief answer. 0.07. What is the difference between the Expenditure(as % of GDP) of Low & middle income in 2004 and the Expenditure(as % of GDP) of Equatorial Guinea in 2007?
Give a very brief answer. 2.95. What is the difference between the Expenditure(as % of GDP) of Low & middle income in 2004 and the Expenditure(as % of GDP) of Nepal in 2007?
Keep it short and to the point. -0.32. What is the difference between the Expenditure(as % of GDP) of Low & middle income in 2004 and the Expenditure(as % of GDP) of Tajikistan in 2007?
Your answer should be compact. -0.15. What is the difference between the Expenditure(as % of GDP) in Equatorial Guinea in 2004 and the Expenditure(as % of GDP) in Nepal in 2007?
Your response must be concise. -3.12. What is the difference between the Expenditure(as % of GDP) in Equatorial Guinea in 2004 and the Expenditure(as % of GDP) in Tajikistan in 2007?
Provide a succinct answer. -2.95. What is the difference between the Expenditure(as % of GDP) in Nepal in 2004 and the Expenditure(as % of GDP) in Tajikistan in 2007?
Make the answer very short. 0.43. What is the difference between the Expenditure(as % of GDP) of Low & middle income in 2005 and the Expenditure(as % of GDP) of Equatorial Guinea in 2006?
Offer a very short reply. 3.19. What is the difference between the Expenditure(as % of GDP) in Low & middle income in 2005 and the Expenditure(as % of GDP) in Nepal in 2006?
Ensure brevity in your answer.  -0.31. What is the difference between the Expenditure(as % of GDP) of Low & middle income in 2005 and the Expenditure(as % of GDP) of Tajikistan in 2006?
Give a very brief answer. -0.38. What is the difference between the Expenditure(as % of GDP) of Equatorial Guinea in 2005 and the Expenditure(as % of GDP) of Nepal in 2006?
Provide a short and direct response. -3.81. What is the difference between the Expenditure(as % of GDP) of Equatorial Guinea in 2005 and the Expenditure(as % of GDP) of Tajikistan in 2006?
Your response must be concise. -3.88. What is the difference between the Expenditure(as % of GDP) in Nepal in 2005 and the Expenditure(as % of GDP) in Tajikistan in 2006?
Your answer should be very brief. 0.02. What is the difference between the Expenditure(as % of GDP) of Low & middle income in 2005 and the Expenditure(as % of GDP) of Equatorial Guinea in 2007?
Your response must be concise. 3.07. What is the difference between the Expenditure(as % of GDP) in Low & middle income in 2005 and the Expenditure(as % of GDP) in Nepal in 2007?
Your answer should be very brief. -0.19. What is the difference between the Expenditure(as % of GDP) in Low & middle income in 2005 and the Expenditure(as % of GDP) in Tajikistan in 2007?
Your answer should be compact. -0.03. What is the difference between the Expenditure(as % of GDP) of Equatorial Guinea in 2005 and the Expenditure(as % of GDP) of Nepal in 2007?
Your response must be concise. -3.69. What is the difference between the Expenditure(as % of GDP) in Equatorial Guinea in 2005 and the Expenditure(as % of GDP) in Tajikistan in 2007?
Offer a very short reply. -3.52. What is the difference between the Expenditure(as % of GDP) of Nepal in 2005 and the Expenditure(as % of GDP) of Tajikistan in 2007?
Provide a short and direct response. 0.38. What is the difference between the Expenditure(as % of GDP) in Low & middle income in 2006 and the Expenditure(as % of GDP) in Equatorial Guinea in 2007?
Your response must be concise. 3.01. What is the difference between the Expenditure(as % of GDP) in Low & middle income in 2006 and the Expenditure(as % of GDP) in Nepal in 2007?
Keep it short and to the point. -0.25. What is the difference between the Expenditure(as % of GDP) in Low & middle income in 2006 and the Expenditure(as % of GDP) in Tajikistan in 2007?
Offer a terse response. -0.09. What is the difference between the Expenditure(as % of GDP) in Equatorial Guinea in 2006 and the Expenditure(as % of GDP) in Nepal in 2007?
Provide a succinct answer. -3.38. What is the difference between the Expenditure(as % of GDP) of Equatorial Guinea in 2006 and the Expenditure(as % of GDP) of Tajikistan in 2007?
Offer a terse response. -3.22. What is the difference between the Expenditure(as % of GDP) in Nepal in 2006 and the Expenditure(as % of GDP) in Tajikistan in 2007?
Your response must be concise. 0.28. What is the average Expenditure(as % of GDP) in Low & middle income per year?
Provide a short and direct response. 5.17. What is the average Expenditure(as % of GDP) of Equatorial Guinea per year?
Give a very brief answer. 2.17. What is the average Expenditure(as % of GDP) of Nepal per year?
Make the answer very short. 5.55. What is the average Expenditure(as % of GDP) of Tajikistan per year?
Your response must be concise. 5.02. In the year 2000, what is the difference between the Expenditure(as % of GDP) of Low & middle income and Expenditure(as % of GDP) of Equatorial Guinea?
Your answer should be very brief. 2.25. In the year 2000, what is the difference between the Expenditure(as % of GDP) of Low & middle income and Expenditure(as % of GDP) of Nepal?
Provide a short and direct response. -0.42. In the year 2000, what is the difference between the Expenditure(as % of GDP) of Low & middle income and Expenditure(as % of GDP) of Tajikistan?
Give a very brief answer. 0.34. In the year 2000, what is the difference between the Expenditure(as % of GDP) of Equatorial Guinea and Expenditure(as % of GDP) of Nepal?
Ensure brevity in your answer.  -2.67. In the year 2000, what is the difference between the Expenditure(as % of GDP) in Equatorial Guinea and Expenditure(as % of GDP) in Tajikistan?
Give a very brief answer. -1.91. In the year 2000, what is the difference between the Expenditure(as % of GDP) in Nepal and Expenditure(as % of GDP) in Tajikistan?
Your answer should be very brief. 0.76. In the year 2001, what is the difference between the Expenditure(as % of GDP) of Low & middle income and Expenditure(as % of GDP) of Equatorial Guinea?
Provide a succinct answer. 3.31. In the year 2001, what is the difference between the Expenditure(as % of GDP) of Low & middle income and Expenditure(as % of GDP) of Nepal?
Provide a succinct answer. -0.23. In the year 2001, what is the difference between the Expenditure(as % of GDP) in Low & middle income and Expenditure(as % of GDP) in Tajikistan?
Provide a short and direct response. 0.51. In the year 2001, what is the difference between the Expenditure(as % of GDP) in Equatorial Guinea and Expenditure(as % of GDP) in Nepal?
Your answer should be compact. -3.54. In the year 2001, what is the difference between the Expenditure(as % of GDP) of Equatorial Guinea and Expenditure(as % of GDP) of Tajikistan?
Offer a very short reply. -2.8. In the year 2001, what is the difference between the Expenditure(as % of GDP) in Nepal and Expenditure(as % of GDP) in Tajikistan?
Ensure brevity in your answer.  0.74. In the year 2002, what is the difference between the Expenditure(as % of GDP) of Low & middle income and Expenditure(as % of GDP) of Equatorial Guinea?
Your answer should be very brief. 3.07. In the year 2002, what is the difference between the Expenditure(as % of GDP) of Low & middle income and Expenditure(as % of GDP) of Nepal?
Provide a short and direct response. -0.44. In the year 2002, what is the difference between the Expenditure(as % of GDP) in Low & middle income and Expenditure(as % of GDP) in Tajikistan?
Provide a succinct answer. 0.65. In the year 2002, what is the difference between the Expenditure(as % of GDP) in Equatorial Guinea and Expenditure(as % of GDP) in Nepal?
Ensure brevity in your answer.  -3.51. In the year 2002, what is the difference between the Expenditure(as % of GDP) of Equatorial Guinea and Expenditure(as % of GDP) of Tajikistan?
Offer a terse response. -2.43. In the year 2002, what is the difference between the Expenditure(as % of GDP) in Nepal and Expenditure(as % of GDP) in Tajikistan?
Your response must be concise. 1.09. In the year 2003, what is the difference between the Expenditure(as % of GDP) in Low & middle income and Expenditure(as % of GDP) in Equatorial Guinea?
Your answer should be compact. 2.94. In the year 2003, what is the difference between the Expenditure(as % of GDP) of Low & middle income and Expenditure(as % of GDP) of Nepal?
Give a very brief answer. -0.28. In the year 2003, what is the difference between the Expenditure(as % of GDP) of Low & middle income and Expenditure(as % of GDP) of Tajikistan?
Your answer should be compact. 0.71. In the year 2003, what is the difference between the Expenditure(as % of GDP) in Equatorial Guinea and Expenditure(as % of GDP) in Nepal?
Ensure brevity in your answer.  -3.21. In the year 2003, what is the difference between the Expenditure(as % of GDP) of Equatorial Guinea and Expenditure(as % of GDP) of Tajikistan?
Give a very brief answer. -2.23. In the year 2003, what is the difference between the Expenditure(as % of GDP) of Nepal and Expenditure(as % of GDP) of Tajikistan?
Give a very brief answer. 0.98. In the year 2004, what is the difference between the Expenditure(as % of GDP) in Low & middle income and Expenditure(as % of GDP) in Equatorial Guinea?
Offer a terse response. 2.8. In the year 2004, what is the difference between the Expenditure(as % of GDP) in Low & middle income and Expenditure(as % of GDP) in Nepal?
Your answer should be compact. -0.58. In the year 2004, what is the difference between the Expenditure(as % of GDP) of Low & middle income and Expenditure(as % of GDP) of Tajikistan?
Your answer should be compact. 0.12. In the year 2004, what is the difference between the Expenditure(as % of GDP) in Equatorial Guinea and Expenditure(as % of GDP) in Nepal?
Provide a short and direct response. -3.38. In the year 2004, what is the difference between the Expenditure(as % of GDP) in Equatorial Guinea and Expenditure(as % of GDP) in Tajikistan?
Your answer should be compact. -2.67. In the year 2004, what is the difference between the Expenditure(as % of GDP) of Nepal and Expenditure(as % of GDP) of Tajikistan?
Ensure brevity in your answer.  0.7. In the year 2005, what is the difference between the Expenditure(as % of GDP) of Low & middle income and Expenditure(as % of GDP) of Equatorial Guinea?
Provide a succinct answer. 3.5. In the year 2005, what is the difference between the Expenditure(as % of GDP) in Low & middle income and Expenditure(as % of GDP) in Nepal?
Keep it short and to the point. -0.4. In the year 2005, what is the difference between the Expenditure(as % of GDP) in Low & middle income and Expenditure(as % of GDP) in Tajikistan?
Your answer should be very brief. -0.57. In the year 2005, what is the difference between the Expenditure(as % of GDP) of Equatorial Guinea and Expenditure(as % of GDP) of Tajikistan?
Your answer should be very brief. -4.06. In the year 2005, what is the difference between the Expenditure(as % of GDP) of Nepal and Expenditure(as % of GDP) of Tajikistan?
Your answer should be compact. -0.16. In the year 2006, what is the difference between the Expenditure(as % of GDP) in Low & middle income and Expenditure(as % of GDP) in Equatorial Guinea?
Give a very brief answer. 3.13. In the year 2006, what is the difference between the Expenditure(as % of GDP) of Low & middle income and Expenditure(as % of GDP) of Nepal?
Make the answer very short. -0.37. In the year 2006, what is the difference between the Expenditure(as % of GDP) of Low & middle income and Expenditure(as % of GDP) of Tajikistan?
Provide a succinct answer. -0.44. In the year 2006, what is the difference between the Expenditure(as % of GDP) in Equatorial Guinea and Expenditure(as % of GDP) in Nepal?
Make the answer very short. -3.5. In the year 2006, what is the difference between the Expenditure(as % of GDP) of Equatorial Guinea and Expenditure(as % of GDP) of Tajikistan?
Ensure brevity in your answer.  -3.57. In the year 2006, what is the difference between the Expenditure(as % of GDP) of Nepal and Expenditure(as % of GDP) of Tajikistan?
Make the answer very short. -0.07. In the year 2007, what is the difference between the Expenditure(as % of GDP) in Low & middle income and Expenditure(as % of GDP) in Equatorial Guinea?
Provide a succinct answer. 2.97. In the year 2007, what is the difference between the Expenditure(as % of GDP) of Low & middle income and Expenditure(as % of GDP) of Nepal?
Give a very brief answer. -0.3. In the year 2007, what is the difference between the Expenditure(as % of GDP) of Low & middle income and Expenditure(as % of GDP) of Tajikistan?
Your response must be concise. -0.13. In the year 2007, what is the difference between the Expenditure(as % of GDP) of Equatorial Guinea and Expenditure(as % of GDP) of Nepal?
Provide a short and direct response. -3.27. In the year 2007, what is the difference between the Expenditure(as % of GDP) of Equatorial Guinea and Expenditure(as % of GDP) of Tajikistan?
Ensure brevity in your answer.  -3.1. In the year 2007, what is the difference between the Expenditure(as % of GDP) in Nepal and Expenditure(as % of GDP) in Tajikistan?
Your response must be concise. 0.17. What is the ratio of the Expenditure(as % of GDP) in Low & middle income in 2000 to that in 2001?
Your response must be concise. 0.98. What is the ratio of the Expenditure(as % of GDP) in Equatorial Guinea in 2000 to that in 2001?
Ensure brevity in your answer.  1.53. What is the ratio of the Expenditure(as % of GDP) of Nepal in 2000 to that in 2001?
Your answer should be very brief. 1.01. What is the ratio of the Expenditure(as % of GDP) of Tajikistan in 2000 to that in 2001?
Your answer should be very brief. 1.01. What is the ratio of the Expenditure(as % of GDP) in Low & middle income in 2000 to that in 2002?
Provide a succinct answer. 0.97. What is the ratio of the Expenditure(as % of GDP) of Equatorial Guinea in 2000 to that in 2002?
Make the answer very short. 1.33. What is the ratio of the Expenditure(as % of GDP) of Tajikistan in 2000 to that in 2002?
Your answer should be compact. 1.04. What is the ratio of the Expenditure(as % of GDP) of Low & middle income in 2000 to that in 2003?
Your response must be concise. 0.96. What is the ratio of the Expenditure(as % of GDP) in Equatorial Guinea in 2000 to that in 2003?
Offer a terse response. 1.23. What is the ratio of the Expenditure(as % of GDP) of Nepal in 2000 to that in 2003?
Ensure brevity in your answer.  0.99. What is the ratio of the Expenditure(as % of GDP) in Tajikistan in 2000 to that in 2003?
Offer a terse response. 1.04. What is the ratio of the Expenditure(as % of GDP) in Low & middle income in 2000 to that in 2004?
Keep it short and to the point. 0.96. What is the ratio of the Expenditure(as % of GDP) in Equatorial Guinea in 2000 to that in 2004?
Your answer should be very brief. 1.14. What is the ratio of the Expenditure(as % of GDP) in Nepal in 2000 to that in 2004?
Keep it short and to the point. 0.94. What is the ratio of the Expenditure(as % of GDP) in Tajikistan in 2000 to that in 2004?
Make the answer very short. 0.92. What is the ratio of the Expenditure(as % of GDP) of Low & middle income in 2000 to that in 2005?
Provide a succinct answer. 0.94. What is the ratio of the Expenditure(as % of GDP) in Equatorial Guinea in 2000 to that in 2005?
Offer a very short reply. 1.5. What is the ratio of the Expenditure(as % of GDP) in Tajikistan in 2000 to that in 2005?
Ensure brevity in your answer.  0.79. What is the ratio of the Expenditure(as % of GDP) of Low & middle income in 2000 to that in 2006?
Give a very brief answer. 0.95. What is the ratio of the Expenditure(as % of GDP) of Equatorial Guinea in 2000 to that in 2006?
Make the answer very short. 1.28. What is the ratio of the Expenditure(as % of GDP) in Tajikistan in 2000 to that in 2006?
Your response must be concise. 0.81. What is the ratio of the Expenditure(as % of GDP) of Low & middle income in 2000 to that in 2007?
Provide a short and direct response. 0.95. What is the ratio of the Expenditure(as % of GDP) in Equatorial Guinea in 2000 to that in 2007?
Keep it short and to the point. 1.22. What is the ratio of the Expenditure(as % of GDP) of Nepal in 2000 to that in 2007?
Your response must be concise. 0.98. What is the ratio of the Expenditure(as % of GDP) of Tajikistan in 2000 to that in 2007?
Keep it short and to the point. 0.87. What is the ratio of the Expenditure(as % of GDP) of Equatorial Guinea in 2001 to that in 2002?
Your answer should be compact. 0.87. What is the ratio of the Expenditure(as % of GDP) of Nepal in 2001 to that in 2002?
Your answer should be compact. 0.96. What is the ratio of the Expenditure(as % of GDP) in Tajikistan in 2001 to that in 2002?
Provide a succinct answer. 1.02. What is the ratio of the Expenditure(as % of GDP) in Low & middle income in 2001 to that in 2003?
Provide a succinct answer. 0.99. What is the ratio of the Expenditure(as % of GDP) in Equatorial Guinea in 2001 to that in 2003?
Offer a very short reply. 0.8. What is the ratio of the Expenditure(as % of GDP) in Nepal in 2001 to that in 2003?
Your answer should be compact. 0.98. What is the ratio of the Expenditure(as % of GDP) of Tajikistan in 2001 to that in 2003?
Keep it short and to the point. 1.03. What is the ratio of the Expenditure(as % of GDP) of Low & middle income in 2001 to that in 2004?
Provide a succinct answer. 0.98. What is the ratio of the Expenditure(as % of GDP) of Equatorial Guinea in 2001 to that in 2004?
Make the answer very short. 0.74. What is the ratio of the Expenditure(as % of GDP) of Nepal in 2001 to that in 2004?
Ensure brevity in your answer.  0.92. What is the ratio of the Expenditure(as % of GDP) of Tajikistan in 2001 to that in 2004?
Your answer should be very brief. 0.9. What is the ratio of the Expenditure(as % of GDP) in Low & middle income in 2001 to that in 2005?
Provide a succinct answer. 0.96. What is the ratio of the Expenditure(as % of GDP) in Equatorial Guinea in 2001 to that in 2005?
Keep it short and to the point. 0.98. What is the ratio of the Expenditure(as % of GDP) of Nepal in 2001 to that in 2005?
Your answer should be compact. 0.93. What is the ratio of the Expenditure(as % of GDP) in Tajikistan in 2001 to that in 2005?
Make the answer very short. 0.78. What is the ratio of the Expenditure(as % of GDP) in Low & middle income in 2001 to that in 2006?
Ensure brevity in your answer.  0.97. What is the ratio of the Expenditure(as % of GDP) of Equatorial Guinea in 2001 to that in 2006?
Make the answer very short. 0.84. What is the ratio of the Expenditure(as % of GDP) of Nepal in 2001 to that in 2006?
Keep it short and to the point. 0.95. What is the ratio of the Expenditure(as % of GDP) in Tajikistan in 2001 to that in 2006?
Make the answer very short. 0.8. What is the ratio of the Expenditure(as % of GDP) of Low & middle income in 2001 to that in 2007?
Your answer should be very brief. 0.98. What is the ratio of the Expenditure(as % of GDP) in Equatorial Guinea in 2001 to that in 2007?
Provide a short and direct response. 0.79. What is the ratio of the Expenditure(as % of GDP) of Nepal in 2001 to that in 2007?
Your answer should be compact. 0.97. What is the ratio of the Expenditure(as % of GDP) of Tajikistan in 2001 to that in 2007?
Give a very brief answer. 0.86. What is the ratio of the Expenditure(as % of GDP) in Low & middle income in 2002 to that in 2003?
Your answer should be compact. 0.99. What is the ratio of the Expenditure(as % of GDP) of Equatorial Guinea in 2002 to that in 2003?
Your response must be concise. 0.92. What is the ratio of the Expenditure(as % of GDP) of Nepal in 2002 to that in 2003?
Provide a succinct answer. 1.02. What is the ratio of the Expenditure(as % of GDP) of Low & middle income in 2002 to that in 2004?
Your response must be concise. 0.99. What is the ratio of the Expenditure(as % of GDP) of Equatorial Guinea in 2002 to that in 2004?
Your response must be concise. 0.86. What is the ratio of the Expenditure(as % of GDP) of Nepal in 2002 to that in 2004?
Offer a terse response. 0.96. What is the ratio of the Expenditure(as % of GDP) of Tajikistan in 2002 to that in 2004?
Offer a terse response. 0.88. What is the ratio of the Expenditure(as % of GDP) of Low & middle income in 2002 to that in 2005?
Your answer should be compact. 0.96. What is the ratio of the Expenditure(as % of GDP) in Equatorial Guinea in 2002 to that in 2005?
Offer a very short reply. 1.13. What is the ratio of the Expenditure(as % of GDP) of Nepal in 2002 to that in 2005?
Offer a very short reply. 0.97. What is the ratio of the Expenditure(as % of GDP) of Tajikistan in 2002 to that in 2005?
Your answer should be compact. 0.76. What is the ratio of the Expenditure(as % of GDP) of Low & middle income in 2002 to that in 2006?
Offer a terse response. 0.97. What is the ratio of the Expenditure(as % of GDP) in Equatorial Guinea in 2002 to that in 2006?
Provide a short and direct response. 0.96. What is the ratio of the Expenditure(as % of GDP) in Tajikistan in 2002 to that in 2006?
Your answer should be compact. 0.79. What is the ratio of the Expenditure(as % of GDP) in Low & middle income in 2002 to that in 2007?
Offer a very short reply. 0.98. What is the ratio of the Expenditure(as % of GDP) in Equatorial Guinea in 2002 to that in 2007?
Your response must be concise. 0.91. What is the ratio of the Expenditure(as % of GDP) in Nepal in 2002 to that in 2007?
Your answer should be very brief. 1.01. What is the ratio of the Expenditure(as % of GDP) in Tajikistan in 2002 to that in 2007?
Give a very brief answer. 0.84. What is the ratio of the Expenditure(as % of GDP) in Low & middle income in 2003 to that in 2004?
Give a very brief answer. 0.99. What is the ratio of the Expenditure(as % of GDP) in Nepal in 2003 to that in 2004?
Your answer should be compact. 0.94. What is the ratio of the Expenditure(as % of GDP) in Tajikistan in 2003 to that in 2004?
Offer a terse response. 0.88. What is the ratio of the Expenditure(as % of GDP) in Low & middle income in 2003 to that in 2005?
Give a very brief answer. 0.97. What is the ratio of the Expenditure(as % of GDP) of Equatorial Guinea in 2003 to that in 2005?
Offer a very short reply. 1.22. What is the ratio of the Expenditure(as % of GDP) of Nepal in 2003 to that in 2005?
Make the answer very short. 0.95. What is the ratio of the Expenditure(as % of GDP) in Tajikistan in 2003 to that in 2005?
Ensure brevity in your answer.  0.76. What is the ratio of the Expenditure(as % of GDP) of Low & middle income in 2003 to that in 2006?
Offer a terse response. 0.98. What is the ratio of the Expenditure(as % of GDP) of Equatorial Guinea in 2003 to that in 2006?
Keep it short and to the point. 1.05. What is the ratio of the Expenditure(as % of GDP) in Nepal in 2003 to that in 2006?
Keep it short and to the point. 0.97. What is the ratio of the Expenditure(as % of GDP) in Tajikistan in 2003 to that in 2006?
Your answer should be compact. 0.78. What is the ratio of the Expenditure(as % of GDP) of Equatorial Guinea in 2003 to that in 2007?
Offer a terse response. 0.99. What is the ratio of the Expenditure(as % of GDP) of Nepal in 2003 to that in 2007?
Your answer should be very brief. 0.99. What is the ratio of the Expenditure(as % of GDP) of Tajikistan in 2003 to that in 2007?
Offer a very short reply. 0.83. What is the ratio of the Expenditure(as % of GDP) of Low & middle income in 2004 to that in 2005?
Give a very brief answer. 0.98. What is the ratio of the Expenditure(as % of GDP) of Equatorial Guinea in 2004 to that in 2005?
Make the answer very short. 1.32. What is the ratio of the Expenditure(as % of GDP) in Nepal in 2004 to that in 2005?
Keep it short and to the point. 1.01. What is the ratio of the Expenditure(as % of GDP) in Tajikistan in 2004 to that in 2005?
Offer a terse response. 0.86. What is the ratio of the Expenditure(as % of GDP) of Low & middle income in 2004 to that in 2006?
Make the answer very short. 0.99. What is the ratio of the Expenditure(as % of GDP) in Equatorial Guinea in 2004 to that in 2006?
Your response must be concise. 1.13. What is the ratio of the Expenditure(as % of GDP) of Nepal in 2004 to that in 2006?
Your answer should be very brief. 1.03. What is the ratio of the Expenditure(as % of GDP) of Tajikistan in 2004 to that in 2006?
Give a very brief answer. 0.89. What is the ratio of the Expenditure(as % of GDP) in Equatorial Guinea in 2004 to that in 2007?
Provide a succinct answer. 1.07. What is the ratio of the Expenditure(as % of GDP) in Nepal in 2004 to that in 2007?
Keep it short and to the point. 1.05. What is the ratio of the Expenditure(as % of GDP) of Tajikistan in 2004 to that in 2007?
Your answer should be compact. 0.95. What is the ratio of the Expenditure(as % of GDP) of Low & middle income in 2005 to that in 2006?
Your answer should be compact. 1.01. What is the ratio of the Expenditure(as % of GDP) of Equatorial Guinea in 2005 to that in 2006?
Offer a very short reply. 0.86. What is the ratio of the Expenditure(as % of GDP) of Nepal in 2005 to that in 2006?
Your response must be concise. 1.02. What is the ratio of the Expenditure(as % of GDP) in Tajikistan in 2005 to that in 2006?
Offer a terse response. 1.03. What is the ratio of the Expenditure(as % of GDP) in Low & middle income in 2005 to that in 2007?
Ensure brevity in your answer.  1.02. What is the ratio of the Expenditure(as % of GDP) of Equatorial Guinea in 2005 to that in 2007?
Keep it short and to the point. 0.81. What is the ratio of the Expenditure(as % of GDP) of Nepal in 2005 to that in 2007?
Your answer should be very brief. 1.04. What is the ratio of the Expenditure(as % of GDP) in Tajikistan in 2005 to that in 2007?
Give a very brief answer. 1.1. What is the ratio of the Expenditure(as % of GDP) in Low & middle income in 2006 to that in 2007?
Offer a very short reply. 1.01. What is the ratio of the Expenditure(as % of GDP) of Equatorial Guinea in 2006 to that in 2007?
Provide a short and direct response. 0.95. What is the ratio of the Expenditure(as % of GDP) in Nepal in 2006 to that in 2007?
Offer a terse response. 1.02. What is the ratio of the Expenditure(as % of GDP) of Tajikistan in 2006 to that in 2007?
Offer a terse response. 1.07. What is the difference between the highest and the second highest Expenditure(as % of GDP) of Low & middle income?
Ensure brevity in your answer.  0.06. What is the difference between the highest and the second highest Expenditure(as % of GDP) of Equatorial Guinea?
Ensure brevity in your answer.  0.34. What is the difference between the highest and the second highest Expenditure(as % of GDP) in Nepal?
Ensure brevity in your answer.  0.05. What is the difference between the highest and the second highest Expenditure(as % of GDP) of Tajikistan?
Provide a succinct answer. 0.18. What is the difference between the highest and the lowest Expenditure(as % of GDP) of Low & middle income?
Offer a terse response. 0.34. What is the difference between the highest and the lowest Expenditure(as % of GDP) of Equatorial Guinea?
Provide a succinct answer. 0.95. What is the difference between the highest and the lowest Expenditure(as % of GDP) of Nepal?
Your answer should be very brief. 0.45. What is the difference between the highest and the lowest Expenditure(as % of GDP) in Tajikistan?
Keep it short and to the point. 1.43. 